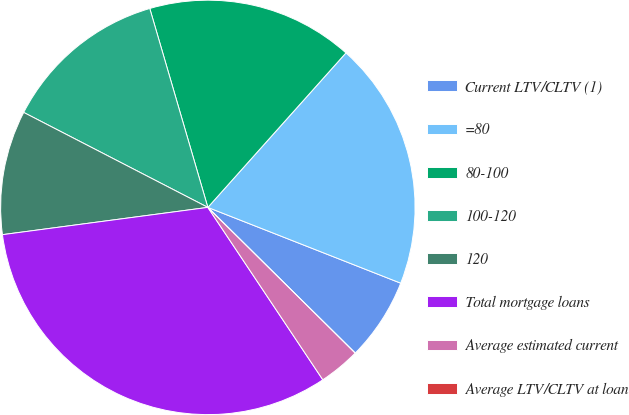<chart> <loc_0><loc_0><loc_500><loc_500><pie_chart><fcel>Current LTV/CLTV (1)<fcel>=80<fcel>80-100<fcel>100-120<fcel>120<fcel>Total mortgage loans<fcel>Average estimated current<fcel>Average LTV/CLTV at loan<nl><fcel>6.45%<fcel>19.35%<fcel>16.13%<fcel>12.9%<fcel>9.68%<fcel>32.26%<fcel>3.23%<fcel>0.0%<nl></chart> 